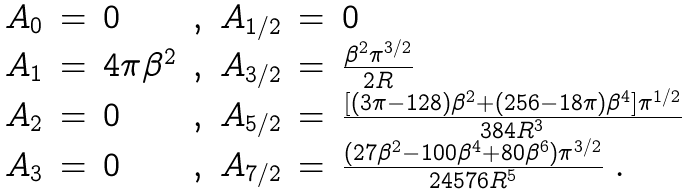<formula> <loc_0><loc_0><loc_500><loc_500>\begin{array} { l c l c c c l } A _ { 0 } & = & 0 & , & A _ { 1 / 2 } & = & 0 \\ A _ { 1 } & = & 4 \pi \beta ^ { 2 } & , & A _ { 3 / 2 } & = & \frac { \beta ^ { 2 } \pi ^ { 3 / 2 } } { 2 R } \\ A _ { 2 } & = & 0 & , & A _ { 5 / 2 } & = & \frac { [ ( 3 \pi - 1 2 8 ) \beta ^ { 2 } + ( 2 5 6 - 1 8 \pi ) \beta ^ { 4 } ] \pi ^ { 1 / 2 } } { 3 8 4 R ^ { 3 } } \\ A _ { 3 } & = & 0 & , & A _ { 7 / 2 } & = & \frac { ( 2 7 \beta ^ { 2 } - 1 0 0 \beta ^ { 4 } + 8 0 \beta ^ { 6 } ) \pi ^ { 3 / 2 } } { 2 4 5 7 6 R ^ { 5 } } \ . \\ \end{array}</formula> 